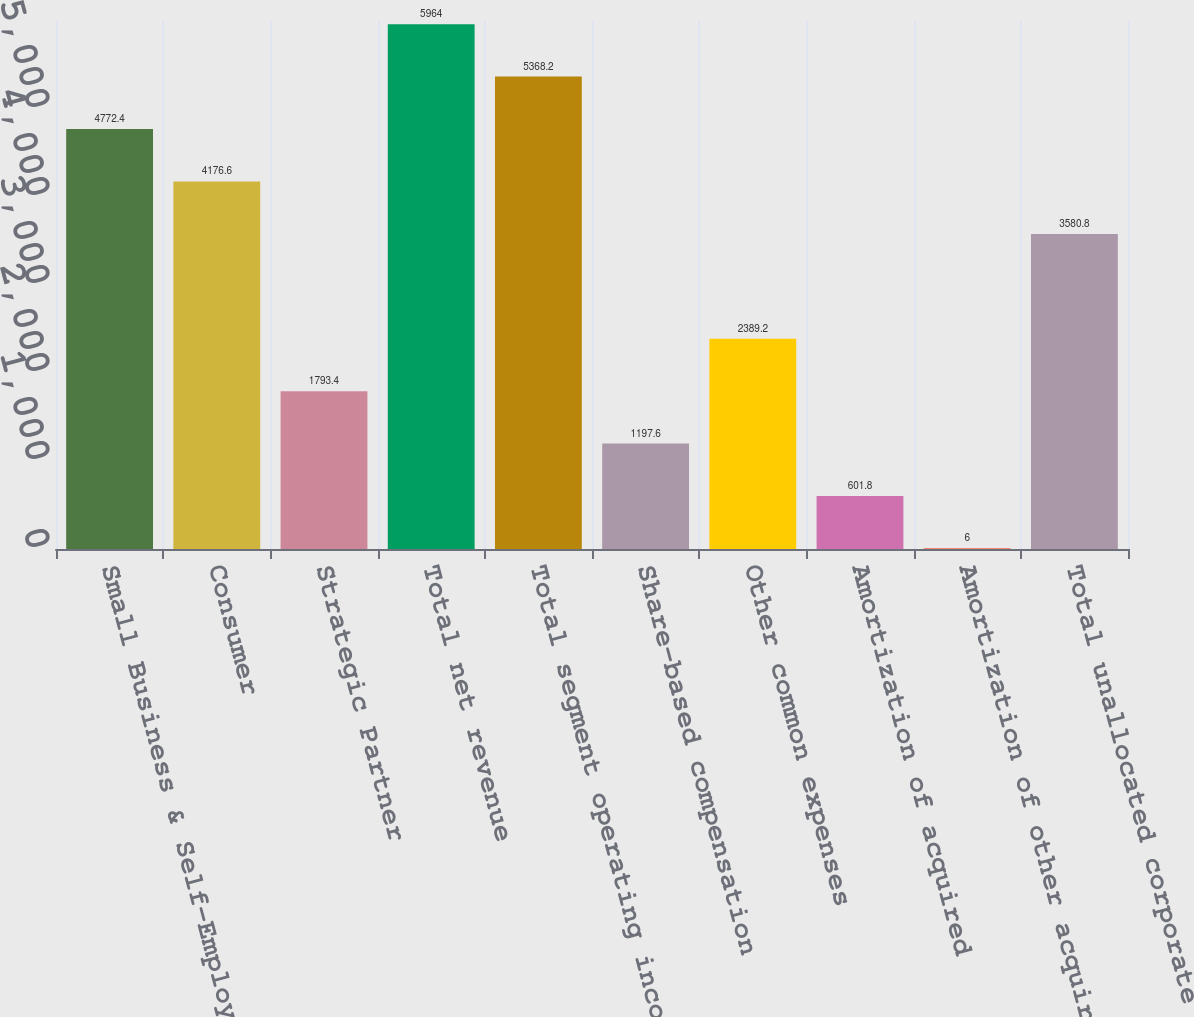Convert chart to OTSL. <chart><loc_0><loc_0><loc_500><loc_500><bar_chart><fcel>Small Business & Self-Employed<fcel>Consumer<fcel>Strategic Partner<fcel>Total net revenue<fcel>Total segment operating income<fcel>Share-based compensation<fcel>Other common expenses<fcel>Amortization of acquired<fcel>Amortization of other acquired<fcel>Total unallocated corporate<nl><fcel>4772.4<fcel>4176.6<fcel>1793.4<fcel>5964<fcel>5368.2<fcel>1197.6<fcel>2389.2<fcel>601.8<fcel>6<fcel>3580.8<nl></chart> 